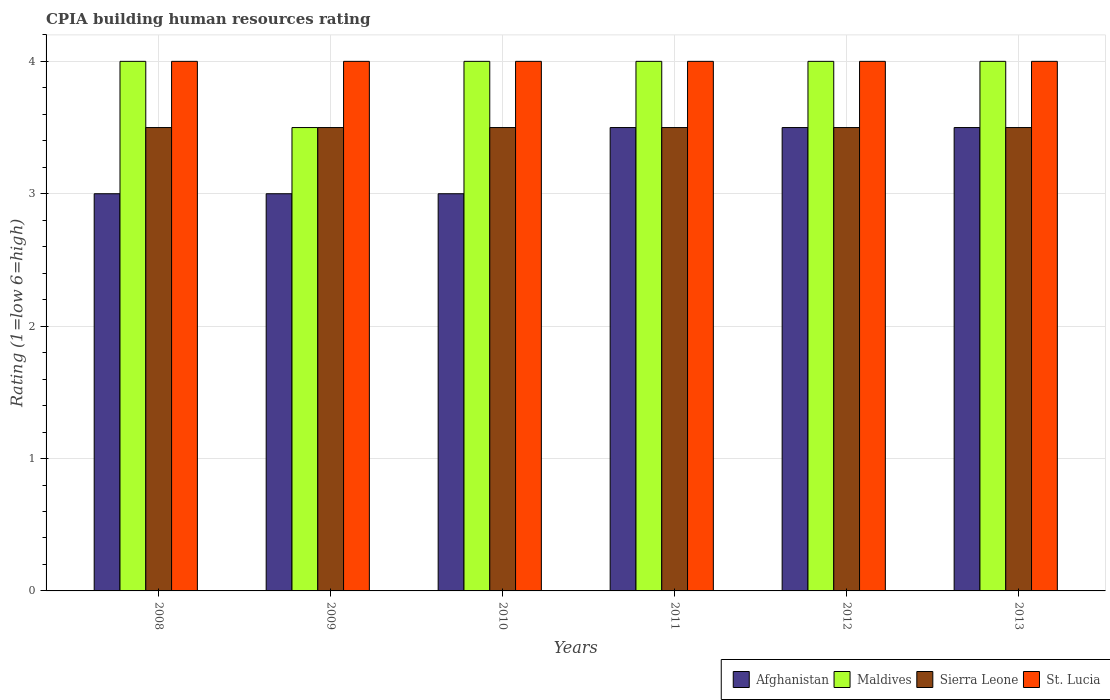How many different coloured bars are there?
Give a very brief answer. 4. How many groups of bars are there?
Provide a succinct answer. 6. What is the label of the 4th group of bars from the left?
Keep it short and to the point. 2011. In how many cases, is the number of bars for a given year not equal to the number of legend labels?
Ensure brevity in your answer.  0. What is the CPIA rating in Maldives in 2012?
Your answer should be very brief. 4. Across all years, what is the minimum CPIA rating in St. Lucia?
Provide a short and direct response. 4. In which year was the CPIA rating in Maldives maximum?
Make the answer very short. 2008. What is the total CPIA rating in St. Lucia in the graph?
Keep it short and to the point. 24. What is the difference between the CPIA rating in Afghanistan in 2008 and that in 2010?
Provide a succinct answer. 0. What is the average CPIA rating in Maldives per year?
Offer a very short reply. 3.92. In how many years, is the CPIA rating in St. Lucia greater than 0.8?
Keep it short and to the point. 6. What is the ratio of the CPIA rating in Afghanistan in 2008 to that in 2012?
Offer a terse response. 0.86. Is the CPIA rating in Maldives in 2009 less than that in 2012?
Your answer should be very brief. Yes. What is the difference between the highest and the lowest CPIA rating in St. Lucia?
Offer a terse response. 0. Is the sum of the CPIA rating in Afghanistan in 2012 and 2013 greater than the maximum CPIA rating in Maldives across all years?
Provide a succinct answer. Yes. What does the 2nd bar from the left in 2011 represents?
Make the answer very short. Maldives. What does the 3rd bar from the right in 2008 represents?
Offer a very short reply. Maldives. How many bars are there?
Ensure brevity in your answer.  24. How many years are there in the graph?
Keep it short and to the point. 6. What is the difference between two consecutive major ticks on the Y-axis?
Provide a short and direct response. 1. Does the graph contain grids?
Make the answer very short. Yes. Where does the legend appear in the graph?
Keep it short and to the point. Bottom right. How many legend labels are there?
Your answer should be very brief. 4. How are the legend labels stacked?
Offer a terse response. Horizontal. What is the title of the graph?
Your answer should be very brief. CPIA building human resources rating. What is the label or title of the Y-axis?
Offer a terse response. Rating (1=low 6=high). What is the Rating (1=low 6=high) of Sierra Leone in 2008?
Offer a terse response. 3.5. What is the Rating (1=low 6=high) in Maldives in 2009?
Make the answer very short. 3.5. What is the Rating (1=low 6=high) in Sierra Leone in 2009?
Your answer should be very brief. 3.5. What is the Rating (1=low 6=high) of Maldives in 2010?
Your answer should be compact. 4. What is the Rating (1=low 6=high) of St. Lucia in 2010?
Offer a terse response. 4. What is the Rating (1=low 6=high) of Sierra Leone in 2011?
Provide a succinct answer. 3.5. What is the Rating (1=low 6=high) in Afghanistan in 2012?
Provide a succinct answer. 3.5. What is the Rating (1=low 6=high) in Maldives in 2012?
Provide a short and direct response. 4. What is the Rating (1=low 6=high) of St. Lucia in 2012?
Keep it short and to the point. 4. What is the Rating (1=low 6=high) of Maldives in 2013?
Offer a terse response. 4. What is the Rating (1=low 6=high) of Sierra Leone in 2013?
Give a very brief answer. 3.5. What is the Rating (1=low 6=high) of St. Lucia in 2013?
Provide a succinct answer. 4. Across all years, what is the maximum Rating (1=low 6=high) of Afghanistan?
Your response must be concise. 3.5. Across all years, what is the maximum Rating (1=low 6=high) in Maldives?
Offer a very short reply. 4. Across all years, what is the maximum Rating (1=low 6=high) in Sierra Leone?
Your answer should be very brief. 3.5. Across all years, what is the maximum Rating (1=low 6=high) in St. Lucia?
Ensure brevity in your answer.  4. Across all years, what is the minimum Rating (1=low 6=high) in Maldives?
Offer a very short reply. 3.5. Across all years, what is the minimum Rating (1=low 6=high) in Sierra Leone?
Your answer should be compact. 3.5. Across all years, what is the minimum Rating (1=low 6=high) of St. Lucia?
Offer a terse response. 4. What is the total Rating (1=low 6=high) of Maldives in the graph?
Offer a very short reply. 23.5. What is the total Rating (1=low 6=high) of Sierra Leone in the graph?
Your answer should be very brief. 21. What is the difference between the Rating (1=low 6=high) of Afghanistan in 2008 and that in 2009?
Offer a terse response. 0. What is the difference between the Rating (1=low 6=high) of Maldives in 2008 and that in 2009?
Keep it short and to the point. 0.5. What is the difference between the Rating (1=low 6=high) of Afghanistan in 2008 and that in 2011?
Your answer should be compact. -0.5. What is the difference between the Rating (1=low 6=high) of Maldives in 2008 and that in 2011?
Your answer should be compact. 0. What is the difference between the Rating (1=low 6=high) of Sierra Leone in 2008 and that in 2011?
Offer a terse response. 0. What is the difference between the Rating (1=low 6=high) in Afghanistan in 2009 and that in 2010?
Make the answer very short. 0. What is the difference between the Rating (1=low 6=high) of Maldives in 2009 and that in 2010?
Provide a short and direct response. -0.5. What is the difference between the Rating (1=low 6=high) in Sierra Leone in 2009 and that in 2010?
Provide a succinct answer. 0. What is the difference between the Rating (1=low 6=high) in St. Lucia in 2009 and that in 2010?
Your answer should be very brief. 0. What is the difference between the Rating (1=low 6=high) of Sierra Leone in 2009 and that in 2011?
Keep it short and to the point. 0. What is the difference between the Rating (1=low 6=high) in St. Lucia in 2009 and that in 2011?
Your answer should be very brief. 0. What is the difference between the Rating (1=low 6=high) of Afghanistan in 2009 and that in 2013?
Offer a very short reply. -0.5. What is the difference between the Rating (1=low 6=high) in Maldives in 2010 and that in 2012?
Make the answer very short. 0. What is the difference between the Rating (1=low 6=high) in St. Lucia in 2010 and that in 2012?
Ensure brevity in your answer.  0. What is the difference between the Rating (1=low 6=high) of Afghanistan in 2010 and that in 2013?
Offer a very short reply. -0.5. What is the difference between the Rating (1=low 6=high) in Sierra Leone in 2010 and that in 2013?
Keep it short and to the point. 0. What is the difference between the Rating (1=low 6=high) of St. Lucia in 2010 and that in 2013?
Your answer should be compact. 0. What is the difference between the Rating (1=low 6=high) in Maldives in 2011 and that in 2012?
Make the answer very short. 0. What is the difference between the Rating (1=low 6=high) of St. Lucia in 2011 and that in 2012?
Your response must be concise. 0. What is the difference between the Rating (1=low 6=high) in Maldives in 2011 and that in 2013?
Ensure brevity in your answer.  0. What is the difference between the Rating (1=low 6=high) in Sierra Leone in 2011 and that in 2013?
Provide a succinct answer. 0. What is the difference between the Rating (1=low 6=high) of Sierra Leone in 2012 and that in 2013?
Your answer should be compact. 0. What is the difference between the Rating (1=low 6=high) in St. Lucia in 2012 and that in 2013?
Give a very brief answer. 0. What is the difference between the Rating (1=low 6=high) in Afghanistan in 2008 and the Rating (1=low 6=high) in Maldives in 2009?
Your response must be concise. -0.5. What is the difference between the Rating (1=low 6=high) of Afghanistan in 2008 and the Rating (1=low 6=high) of Sierra Leone in 2009?
Make the answer very short. -0.5. What is the difference between the Rating (1=low 6=high) in Afghanistan in 2008 and the Rating (1=low 6=high) in St. Lucia in 2009?
Give a very brief answer. -1. What is the difference between the Rating (1=low 6=high) in Maldives in 2008 and the Rating (1=low 6=high) in Sierra Leone in 2009?
Offer a terse response. 0.5. What is the difference between the Rating (1=low 6=high) of Maldives in 2008 and the Rating (1=low 6=high) of St. Lucia in 2009?
Offer a very short reply. 0. What is the difference between the Rating (1=low 6=high) in Sierra Leone in 2008 and the Rating (1=low 6=high) in St. Lucia in 2009?
Provide a short and direct response. -0.5. What is the difference between the Rating (1=low 6=high) in Afghanistan in 2008 and the Rating (1=low 6=high) in Maldives in 2010?
Your answer should be compact. -1. What is the difference between the Rating (1=low 6=high) of Afghanistan in 2008 and the Rating (1=low 6=high) of Sierra Leone in 2010?
Provide a succinct answer. -0.5. What is the difference between the Rating (1=low 6=high) in Afghanistan in 2008 and the Rating (1=low 6=high) in St. Lucia in 2010?
Your answer should be very brief. -1. What is the difference between the Rating (1=low 6=high) of Maldives in 2008 and the Rating (1=low 6=high) of St. Lucia in 2010?
Ensure brevity in your answer.  0. What is the difference between the Rating (1=low 6=high) in Afghanistan in 2008 and the Rating (1=low 6=high) in Maldives in 2011?
Your answer should be compact. -1. What is the difference between the Rating (1=low 6=high) in Afghanistan in 2008 and the Rating (1=low 6=high) in Sierra Leone in 2011?
Your answer should be compact. -0.5. What is the difference between the Rating (1=low 6=high) of Maldives in 2008 and the Rating (1=low 6=high) of Sierra Leone in 2011?
Your answer should be very brief. 0.5. What is the difference between the Rating (1=low 6=high) in Afghanistan in 2008 and the Rating (1=low 6=high) in Maldives in 2012?
Offer a very short reply. -1. What is the difference between the Rating (1=low 6=high) of Afghanistan in 2008 and the Rating (1=low 6=high) of St. Lucia in 2012?
Ensure brevity in your answer.  -1. What is the difference between the Rating (1=low 6=high) of Maldives in 2008 and the Rating (1=low 6=high) of Sierra Leone in 2012?
Ensure brevity in your answer.  0.5. What is the difference between the Rating (1=low 6=high) in Maldives in 2008 and the Rating (1=low 6=high) in St. Lucia in 2012?
Your answer should be very brief. 0. What is the difference between the Rating (1=low 6=high) of Afghanistan in 2008 and the Rating (1=low 6=high) of Maldives in 2013?
Your answer should be very brief. -1. What is the difference between the Rating (1=low 6=high) of Afghanistan in 2008 and the Rating (1=low 6=high) of St. Lucia in 2013?
Ensure brevity in your answer.  -1. What is the difference between the Rating (1=low 6=high) in Maldives in 2008 and the Rating (1=low 6=high) in St. Lucia in 2013?
Your answer should be very brief. 0. What is the difference between the Rating (1=low 6=high) in Sierra Leone in 2008 and the Rating (1=low 6=high) in St. Lucia in 2013?
Your answer should be very brief. -0.5. What is the difference between the Rating (1=low 6=high) of Afghanistan in 2009 and the Rating (1=low 6=high) of Sierra Leone in 2010?
Offer a terse response. -0.5. What is the difference between the Rating (1=low 6=high) in Afghanistan in 2009 and the Rating (1=low 6=high) in St. Lucia in 2010?
Your response must be concise. -1. What is the difference between the Rating (1=low 6=high) of Maldives in 2009 and the Rating (1=low 6=high) of Sierra Leone in 2010?
Make the answer very short. 0. What is the difference between the Rating (1=low 6=high) of Maldives in 2009 and the Rating (1=low 6=high) of St. Lucia in 2010?
Your answer should be very brief. -0.5. What is the difference between the Rating (1=low 6=high) in Sierra Leone in 2009 and the Rating (1=low 6=high) in St. Lucia in 2010?
Make the answer very short. -0.5. What is the difference between the Rating (1=low 6=high) in Afghanistan in 2009 and the Rating (1=low 6=high) in St. Lucia in 2011?
Your answer should be compact. -1. What is the difference between the Rating (1=low 6=high) of Maldives in 2009 and the Rating (1=low 6=high) of St. Lucia in 2011?
Offer a very short reply. -0.5. What is the difference between the Rating (1=low 6=high) in Sierra Leone in 2009 and the Rating (1=low 6=high) in St. Lucia in 2011?
Ensure brevity in your answer.  -0.5. What is the difference between the Rating (1=low 6=high) in Afghanistan in 2009 and the Rating (1=low 6=high) in Maldives in 2012?
Your response must be concise. -1. What is the difference between the Rating (1=low 6=high) of Maldives in 2009 and the Rating (1=low 6=high) of St. Lucia in 2012?
Make the answer very short. -0.5. What is the difference between the Rating (1=low 6=high) in Afghanistan in 2009 and the Rating (1=low 6=high) in Maldives in 2013?
Your answer should be very brief. -1. What is the difference between the Rating (1=low 6=high) of Sierra Leone in 2009 and the Rating (1=low 6=high) of St. Lucia in 2013?
Your answer should be very brief. -0.5. What is the difference between the Rating (1=low 6=high) in Maldives in 2010 and the Rating (1=low 6=high) in Sierra Leone in 2011?
Your answer should be very brief. 0.5. What is the difference between the Rating (1=low 6=high) of Maldives in 2010 and the Rating (1=low 6=high) of St. Lucia in 2011?
Offer a very short reply. 0. What is the difference between the Rating (1=low 6=high) of Afghanistan in 2010 and the Rating (1=low 6=high) of St. Lucia in 2012?
Provide a short and direct response. -1. What is the difference between the Rating (1=low 6=high) of Maldives in 2010 and the Rating (1=low 6=high) of St. Lucia in 2012?
Make the answer very short. 0. What is the difference between the Rating (1=low 6=high) in Sierra Leone in 2010 and the Rating (1=low 6=high) in St. Lucia in 2012?
Offer a very short reply. -0.5. What is the difference between the Rating (1=low 6=high) in Afghanistan in 2010 and the Rating (1=low 6=high) in Maldives in 2013?
Give a very brief answer. -1. What is the difference between the Rating (1=low 6=high) in Afghanistan in 2010 and the Rating (1=low 6=high) in Sierra Leone in 2013?
Ensure brevity in your answer.  -0.5. What is the difference between the Rating (1=low 6=high) in Afghanistan in 2010 and the Rating (1=low 6=high) in St. Lucia in 2013?
Provide a succinct answer. -1. What is the difference between the Rating (1=low 6=high) of Maldives in 2010 and the Rating (1=low 6=high) of Sierra Leone in 2013?
Make the answer very short. 0.5. What is the difference between the Rating (1=low 6=high) in Sierra Leone in 2010 and the Rating (1=low 6=high) in St. Lucia in 2013?
Offer a very short reply. -0.5. What is the difference between the Rating (1=low 6=high) in Maldives in 2011 and the Rating (1=low 6=high) in Sierra Leone in 2012?
Your answer should be compact. 0.5. What is the difference between the Rating (1=low 6=high) in Maldives in 2011 and the Rating (1=low 6=high) in Sierra Leone in 2013?
Provide a short and direct response. 0.5. What is the difference between the Rating (1=low 6=high) in Sierra Leone in 2011 and the Rating (1=low 6=high) in St. Lucia in 2013?
Offer a terse response. -0.5. What is the difference between the Rating (1=low 6=high) of Afghanistan in 2012 and the Rating (1=low 6=high) of Sierra Leone in 2013?
Offer a very short reply. 0. What is the average Rating (1=low 6=high) of Afghanistan per year?
Provide a short and direct response. 3.25. What is the average Rating (1=low 6=high) of Maldives per year?
Offer a terse response. 3.92. What is the average Rating (1=low 6=high) in St. Lucia per year?
Your answer should be compact. 4. In the year 2008, what is the difference between the Rating (1=low 6=high) of Maldives and Rating (1=low 6=high) of St. Lucia?
Give a very brief answer. 0. In the year 2009, what is the difference between the Rating (1=low 6=high) in Afghanistan and Rating (1=low 6=high) in Maldives?
Keep it short and to the point. -0.5. In the year 2009, what is the difference between the Rating (1=low 6=high) in Sierra Leone and Rating (1=low 6=high) in St. Lucia?
Offer a terse response. -0.5. In the year 2010, what is the difference between the Rating (1=low 6=high) of Afghanistan and Rating (1=low 6=high) of Maldives?
Give a very brief answer. -1. In the year 2010, what is the difference between the Rating (1=low 6=high) in Afghanistan and Rating (1=low 6=high) in Sierra Leone?
Keep it short and to the point. -0.5. In the year 2010, what is the difference between the Rating (1=low 6=high) of Afghanistan and Rating (1=low 6=high) of St. Lucia?
Offer a very short reply. -1. In the year 2010, what is the difference between the Rating (1=low 6=high) in Maldives and Rating (1=low 6=high) in Sierra Leone?
Your answer should be very brief. 0.5. In the year 2010, what is the difference between the Rating (1=low 6=high) of Maldives and Rating (1=low 6=high) of St. Lucia?
Make the answer very short. 0. In the year 2011, what is the difference between the Rating (1=low 6=high) of Afghanistan and Rating (1=low 6=high) of Maldives?
Ensure brevity in your answer.  -0.5. In the year 2011, what is the difference between the Rating (1=low 6=high) of Afghanistan and Rating (1=low 6=high) of Sierra Leone?
Your answer should be very brief. 0. In the year 2011, what is the difference between the Rating (1=low 6=high) in Afghanistan and Rating (1=low 6=high) in St. Lucia?
Give a very brief answer. -0.5. In the year 2011, what is the difference between the Rating (1=low 6=high) in Maldives and Rating (1=low 6=high) in St. Lucia?
Your answer should be very brief. 0. In the year 2012, what is the difference between the Rating (1=low 6=high) of Afghanistan and Rating (1=low 6=high) of Maldives?
Provide a short and direct response. -0.5. In the year 2012, what is the difference between the Rating (1=low 6=high) of Afghanistan and Rating (1=low 6=high) of Sierra Leone?
Keep it short and to the point. 0. In the year 2012, what is the difference between the Rating (1=low 6=high) of Maldives and Rating (1=low 6=high) of St. Lucia?
Provide a short and direct response. 0. In the year 2013, what is the difference between the Rating (1=low 6=high) of Afghanistan and Rating (1=low 6=high) of Maldives?
Ensure brevity in your answer.  -0.5. In the year 2013, what is the difference between the Rating (1=low 6=high) of Afghanistan and Rating (1=low 6=high) of Sierra Leone?
Your answer should be very brief. 0. In the year 2013, what is the difference between the Rating (1=low 6=high) in Maldives and Rating (1=low 6=high) in Sierra Leone?
Provide a succinct answer. 0.5. What is the ratio of the Rating (1=low 6=high) in Afghanistan in 2008 to that in 2009?
Your response must be concise. 1. What is the ratio of the Rating (1=low 6=high) of Maldives in 2008 to that in 2009?
Your response must be concise. 1.14. What is the ratio of the Rating (1=low 6=high) in Sierra Leone in 2008 to that in 2009?
Offer a very short reply. 1. What is the ratio of the Rating (1=low 6=high) of St. Lucia in 2008 to that in 2009?
Your answer should be very brief. 1. What is the ratio of the Rating (1=low 6=high) in Afghanistan in 2008 to that in 2010?
Ensure brevity in your answer.  1. What is the ratio of the Rating (1=low 6=high) in Maldives in 2008 to that in 2011?
Keep it short and to the point. 1. What is the ratio of the Rating (1=low 6=high) in Sierra Leone in 2008 to that in 2011?
Offer a very short reply. 1. What is the ratio of the Rating (1=low 6=high) in St. Lucia in 2008 to that in 2011?
Give a very brief answer. 1. What is the ratio of the Rating (1=low 6=high) of Maldives in 2008 to that in 2012?
Your answer should be compact. 1. What is the ratio of the Rating (1=low 6=high) in Sierra Leone in 2008 to that in 2012?
Provide a short and direct response. 1. What is the ratio of the Rating (1=low 6=high) of Maldives in 2008 to that in 2013?
Provide a short and direct response. 1. What is the ratio of the Rating (1=low 6=high) of St. Lucia in 2008 to that in 2013?
Your answer should be very brief. 1. What is the ratio of the Rating (1=low 6=high) in Afghanistan in 2009 to that in 2010?
Your response must be concise. 1. What is the ratio of the Rating (1=low 6=high) in Maldives in 2009 to that in 2010?
Keep it short and to the point. 0.88. What is the ratio of the Rating (1=low 6=high) in Sierra Leone in 2009 to that in 2010?
Ensure brevity in your answer.  1. What is the ratio of the Rating (1=low 6=high) in St. Lucia in 2009 to that in 2010?
Your answer should be compact. 1. What is the ratio of the Rating (1=low 6=high) in Maldives in 2009 to that in 2011?
Ensure brevity in your answer.  0.88. What is the ratio of the Rating (1=low 6=high) in Sierra Leone in 2009 to that in 2011?
Make the answer very short. 1. What is the ratio of the Rating (1=low 6=high) of St. Lucia in 2009 to that in 2011?
Offer a terse response. 1. What is the ratio of the Rating (1=low 6=high) in Sierra Leone in 2009 to that in 2012?
Your response must be concise. 1. What is the ratio of the Rating (1=low 6=high) of St. Lucia in 2009 to that in 2012?
Provide a succinct answer. 1. What is the ratio of the Rating (1=low 6=high) in Sierra Leone in 2009 to that in 2013?
Your answer should be compact. 1. What is the ratio of the Rating (1=low 6=high) in St. Lucia in 2009 to that in 2013?
Your answer should be very brief. 1. What is the ratio of the Rating (1=low 6=high) in Afghanistan in 2010 to that in 2011?
Your answer should be compact. 0.86. What is the ratio of the Rating (1=low 6=high) in Maldives in 2010 to that in 2011?
Ensure brevity in your answer.  1. What is the ratio of the Rating (1=low 6=high) of Afghanistan in 2010 to that in 2012?
Your answer should be very brief. 0.86. What is the ratio of the Rating (1=low 6=high) in Sierra Leone in 2010 to that in 2012?
Provide a succinct answer. 1. What is the ratio of the Rating (1=low 6=high) of St. Lucia in 2010 to that in 2012?
Provide a succinct answer. 1. What is the ratio of the Rating (1=low 6=high) in Afghanistan in 2010 to that in 2013?
Make the answer very short. 0.86. What is the ratio of the Rating (1=low 6=high) of St. Lucia in 2010 to that in 2013?
Your response must be concise. 1. What is the ratio of the Rating (1=low 6=high) of Afghanistan in 2011 to that in 2013?
Your response must be concise. 1. What is the ratio of the Rating (1=low 6=high) in Sierra Leone in 2011 to that in 2013?
Provide a succinct answer. 1. What is the ratio of the Rating (1=low 6=high) of Afghanistan in 2012 to that in 2013?
Ensure brevity in your answer.  1. What is the ratio of the Rating (1=low 6=high) of Maldives in 2012 to that in 2013?
Give a very brief answer. 1. What is the difference between the highest and the second highest Rating (1=low 6=high) in Afghanistan?
Your response must be concise. 0. What is the difference between the highest and the second highest Rating (1=low 6=high) in Sierra Leone?
Your answer should be compact. 0. What is the difference between the highest and the second highest Rating (1=low 6=high) in St. Lucia?
Offer a terse response. 0. 